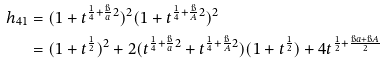<formula> <loc_0><loc_0><loc_500><loc_500>h _ { 4 1 } & = ( 1 + t ^ { \frac { 1 } { 4 } + \frac { \i } { a } 2 } ) ^ { 2 } ( 1 + t ^ { \frac { 1 } { 4 } + \frac { \i } { A } 2 } ) ^ { 2 } \\ & = ( 1 + t ^ { \frac { 1 } { 2 } } ) ^ { 2 } + 2 ( t ^ { \frac { 1 } { 4 } + \frac { \i } { a } 2 } + t ^ { \frac { 1 } { 4 } + \frac { \i } { A } 2 } ) ( 1 + t ^ { \frac { 1 } { 2 } } ) + 4 t ^ { \frac { 1 } { 2 } + \frac { \i a + \i A } 2 }</formula> 